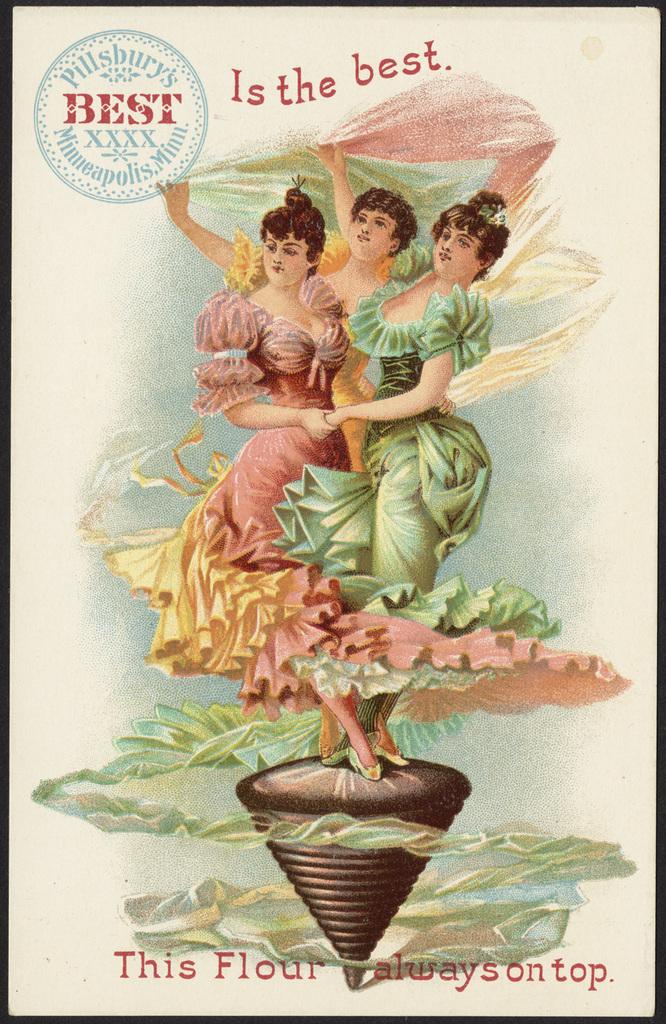What is this product?
Give a very brief answer. Flour. What is the brand name?
Provide a succinct answer. Pillsbury. 